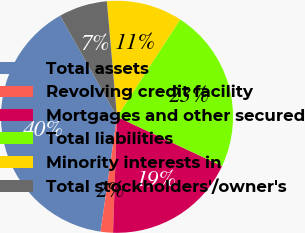<chart> <loc_0><loc_0><loc_500><loc_500><pie_chart><fcel>Total assets<fcel>Revolving credit facility<fcel>Mortgages and other secured<fcel>Total liabilities<fcel>Minority interests in<fcel>Total stockholders'/owner's<nl><fcel>39.58%<fcel>1.72%<fcel>18.57%<fcel>22.82%<fcel>10.55%<fcel>6.76%<nl></chart> 